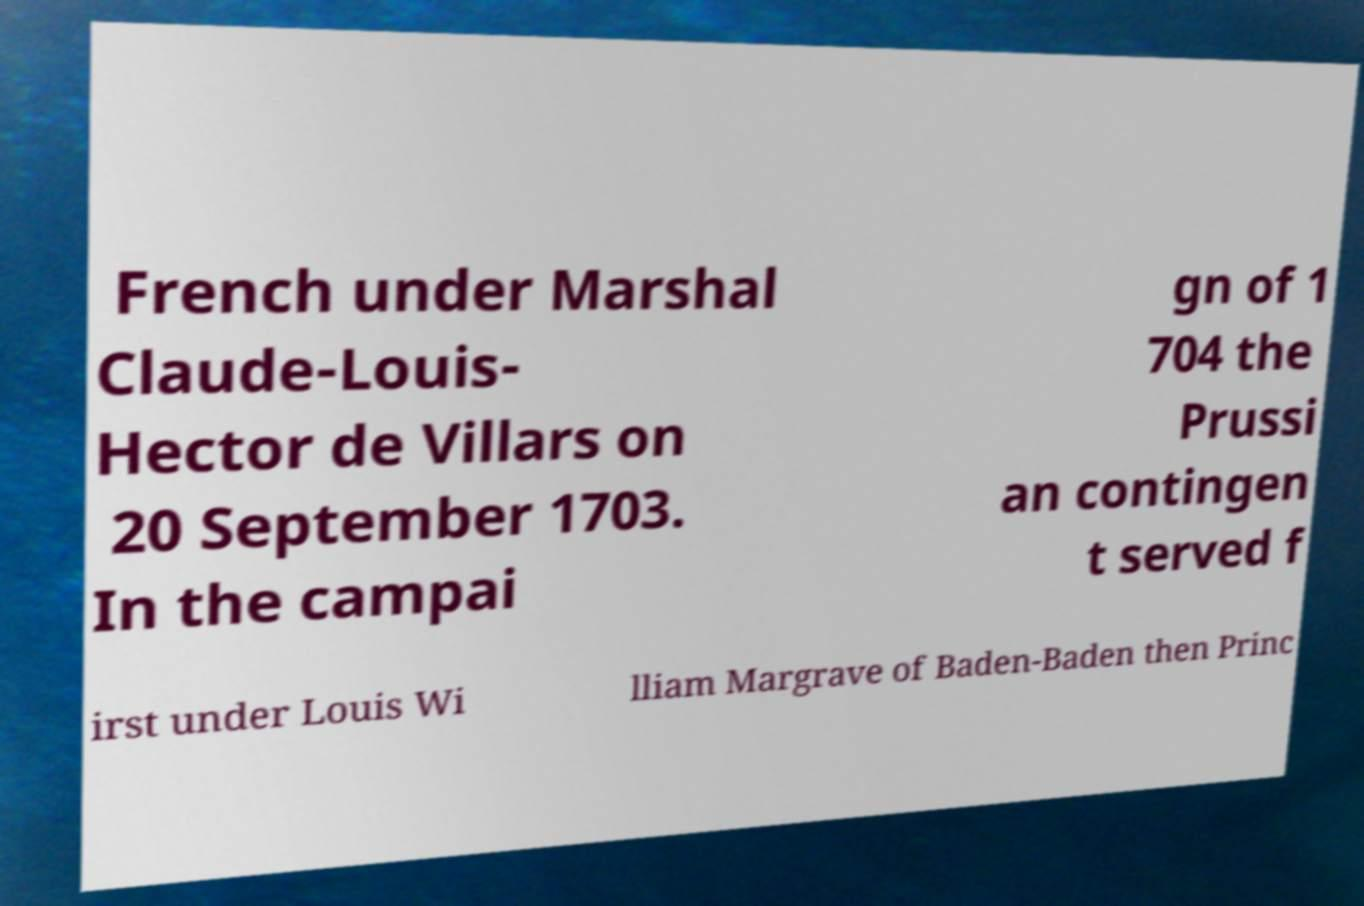There's text embedded in this image that I need extracted. Can you transcribe it verbatim? French under Marshal Claude-Louis- Hector de Villars on 20 September 1703. In the campai gn of 1 704 the Prussi an contingen t served f irst under Louis Wi lliam Margrave of Baden-Baden then Princ 